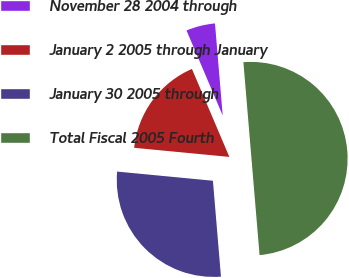Convert chart to OTSL. <chart><loc_0><loc_0><loc_500><loc_500><pie_chart><fcel>November 28 2004 through<fcel>January 2 2005 through January<fcel>January 30 2005 through<fcel>Total Fiscal 2005 Fourth<nl><fcel>5.07%<fcel>17.08%<fcel>27.85%<fcel>50.0%<nl></chart> 